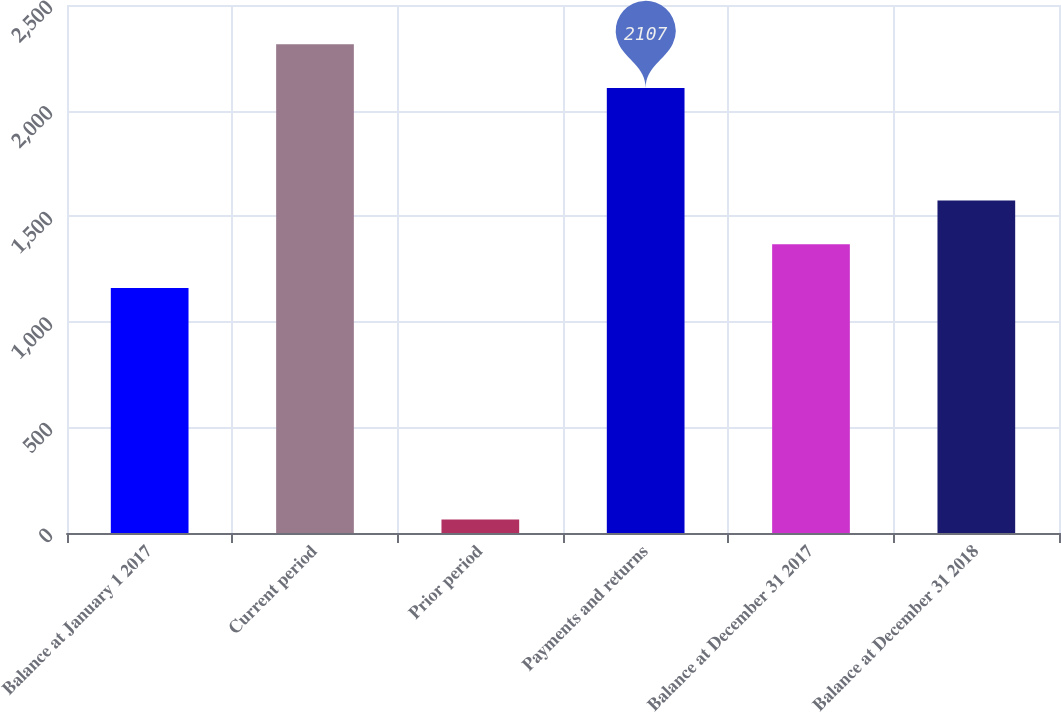Convert chart to OTSL. <chart><loc_0><loc_0><loc_500><loc_500><bar_chart><fcel>Balance at January 1 2017<fcel>Current period<fcel>Prior period<fcel>Payments and returns<fcel>Balance at December 31 2017<fcel>Balance at December 31 2018<nl><fcel>1160<fcel>2314.1<fcel>64<fcel>2107<fcel>1367.1<fcel>1574.2<nl></chart> 